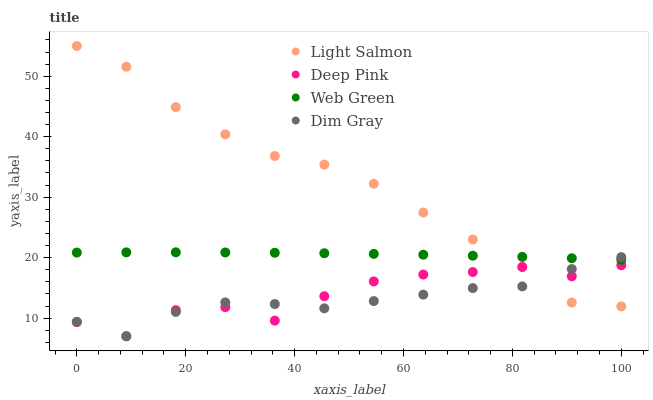Does Dim Gray have the minimum area under the curve?
Answer yes or no. Yes. Does Light Salmon have the maximum area under the curve?
Answer yes or no. Yes. Does Deep Pink have the minimum area under the curve?
Answer yes or no. No. Does Deep Pink have the maximum area under the curve?
Answer yes or no. No. Is Web Green the smoothest?
Answer yes or no. Yes. Is Deep Pink the roughest?
Answer yes or no. Yes. Is Light Salmon the smoothest?
Answer yes or no. No. Is Light Salmon the roughest?
Answer yes or no. No. Does Dim Gray have the lowest value?
Answer yes or no. Yes. Does Light Salmon have the lowest value?
Answer yes or no. No. Does Light Salmon have the highest value?
Answer yes or no. Yes. Does Deep Pink have the highest value?
Answer yes or no. No. Is Deep Pink less than Web Green?
Answer yes or no. Yes. Is Web Green greater than Deep Pink?
Answer yes or no. Yes. Does Dim Gray intersect Web Green?
Answer yes or no. Yes. Is Dim Gray less than Web Green?
Answer yes or no. No. Is Dim Gray greater than Web Green?
Answer yes or no. No. Does Deep Pink intersect Web Green?
Answer yes or no. No. 